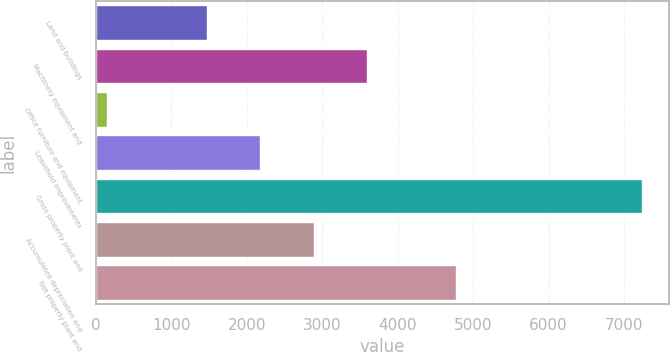Convert chart to OTSL. <chart><loc_0><loc_0><loc_500><loc_500><bar_chart><fcel>Land and buildings<fcel>Machinery equipment and<fcel>Office furniture and equipment<fcel>Leasehold improvements<fcel>Gross property plant and<fcel>Accumulated depreciation and<fcel>Net property plant and<nl><fcel>1471<fcel>3598<fcel>144<fcel>2180<fcel>7234<fcel>2889<fcel>4768<nl></chart> 